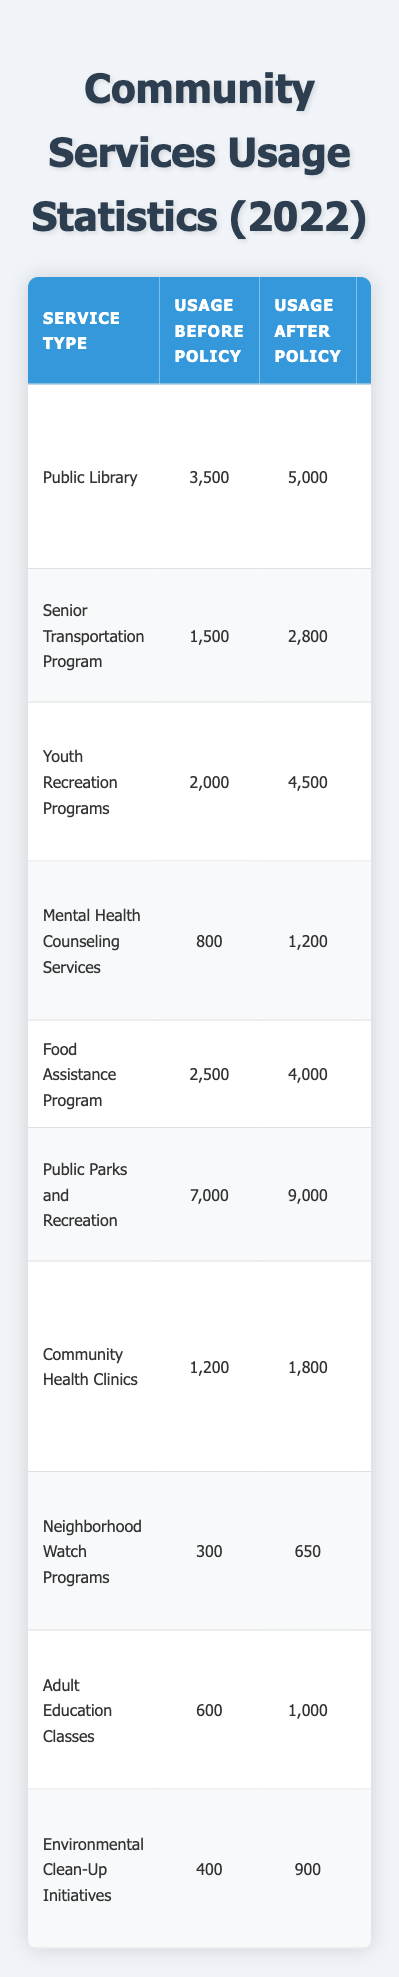What is the usage of the Public Library after the policy change? The usage after the policy change for the Public Library is found in the "Usage After Policy" column. It shows 5000.
Answer: 5000 What was the percentage increase in usage for the Youth Recreation Programs? The usage before policy was 2000, and after it was 4500. The increase is calculated as (4500 - 2000) / 2000 * 100 = 125%.
Answer: 125% Did the Neighborhood Watch Programs see an increase in usage? By comparing the "Usage Before Policy" (300) and "Usage After Policy" (650), there is a clear increase.
Answer: Yes Which service type had the highest increase in usage? Reviewing the increase values for each service type shows Youth Recreation Programs increased by 2500, which is the highest in the table.
Answer: Youth Recreation Programs What is the total usage before the policy changes for all services? Add all the values in the "Usage Before Policy" column: 3500 + 1500 + 2000 + 800 + 2500 + 7000 + 1200 + 300 + 600 + 400 = 19200.
Answer: 19200 Which policy change for the Food Assistance Program contributed to its increased usage? The policy change for the Food Assistance Program was "Expanded eligibility requirements," linked to its increase in usage.
Answer: Expanded eligibility requirements How much total increase in usage was observed across all services? Add the increases: 1500 + 1300 + 2500 + 400 + 1500 + 2000 + 600 + 350 + 400 + 500 = 10900.
Answer: 10900 Was the increase in usage for the Mental Health Counseling Services significant compared to the other services? The increase for Mental Health Counseling Services was 400, which is relatively low compared to others like Youth Recreation Programs (2500); hence, it is less significant.
Answer: No What was the average usage after the policy changes across all services? To find the average, sum all the values in "Usage After Policy": 5000 + 2800 + 4500 + 1200 + 4000 + 9000 + 1800 + 650 + 1000 + 900 = 18050. Divide by the number of services (10) gives 1805.
Answer: 1805 Did any service have a decrease in usage after the policy changes? By examining the "Usage After Policy" column, all services show an increase compared to their respective "Usage Before Policy" values; no decrease is observed.
Answer: No 